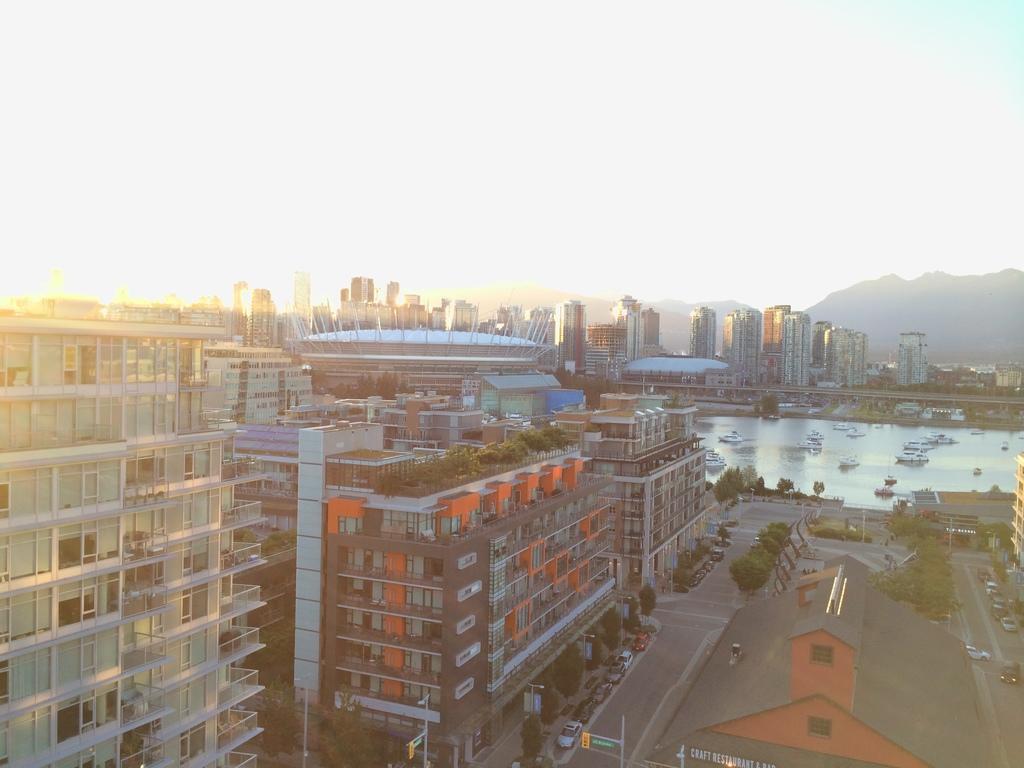How would you summarize this image in a sentence or two? On water there are boats. Here we can see vehicles, trees and buildings with glass windows. Far there is a mountain. 